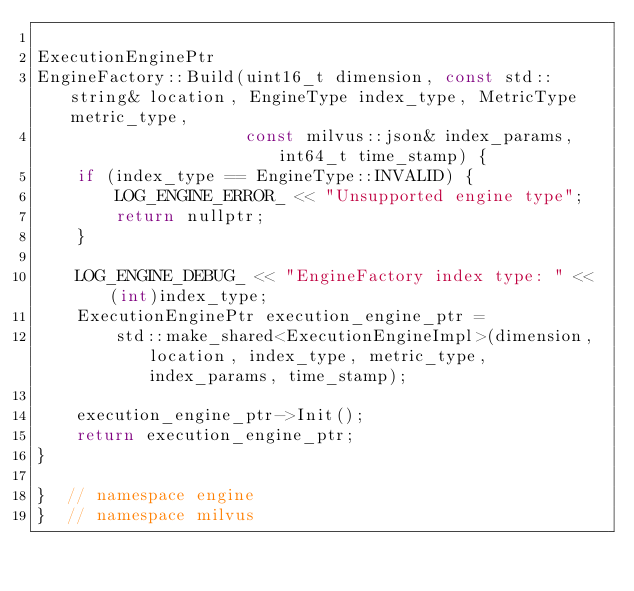Convert code to text. <code><loc_0><loc_0><loc_500><loc_500><_C++_>
ExecutionEnginePtr
EngineFactory::Build(uint16_t dimension, const std::string& location, EngineType index_type, MetricType metric_type,
                     const milvus::json& index_params, int64_t time_stamp) {
    if (index_type == EngineType::INVALID) {
        LOG_ENGINE_ERROR_ << "Unsupported engine type";
        return nullptr;
    }

    LOG_ENGINE_DEBUG_ << "EngineFactory index type: " << (int)index_type;
    ExecutionEnginePtr execution_engine_ptr =
        std::make_shared<ExecutionEngineImpl>(dimension, location, index_type, metric_type, index_params, time_stamp);

    execution_engine_ptr->Init();
    return execution_engine_ptr;
}

}  // namespace engine
}  // namespace milvus
</code> 